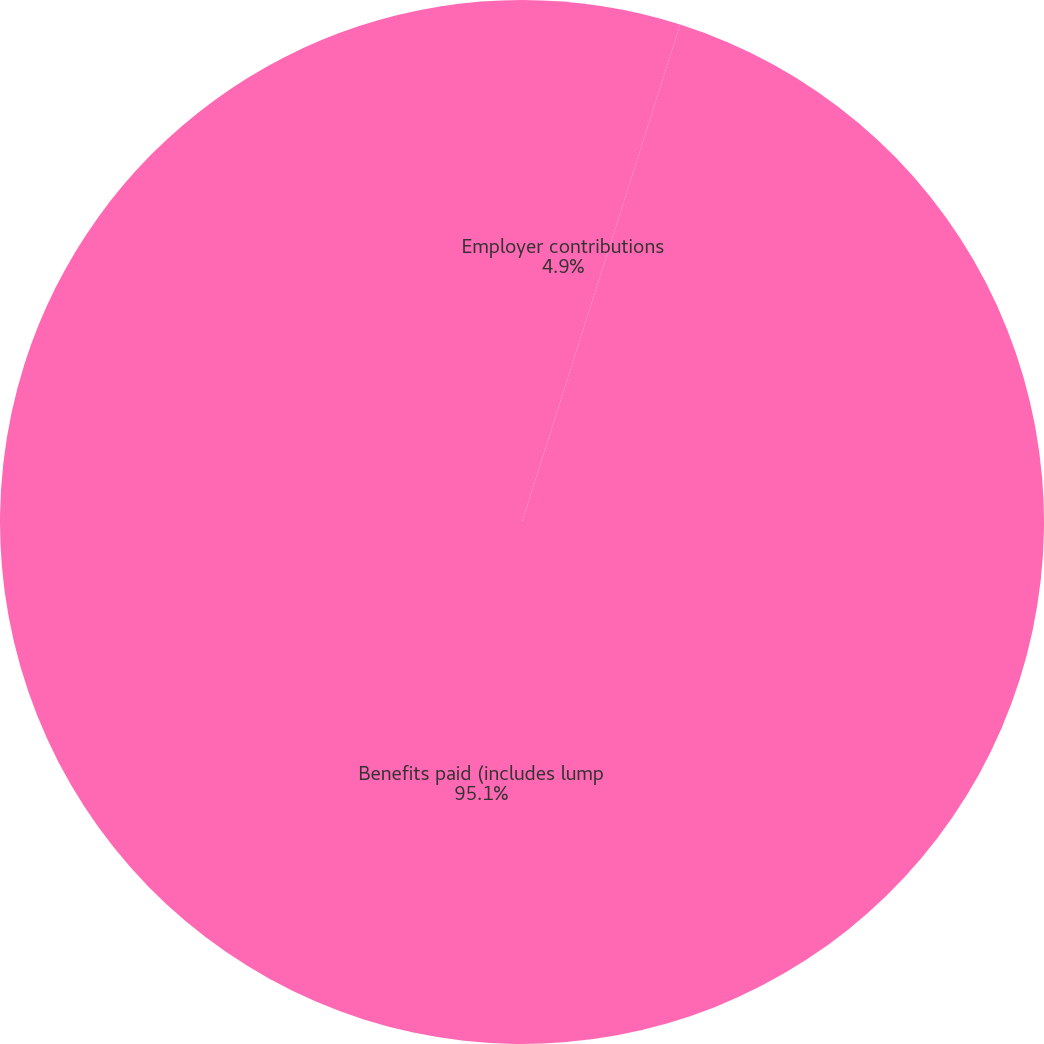<chart> <loc_0><loc_0><loc_500><loc_500><pie_chart><fcel>Employer contributions<fcel>Benefits paid (includes lump<nl><fcel>4.9%<fcel>95.1%<nl></chart> 